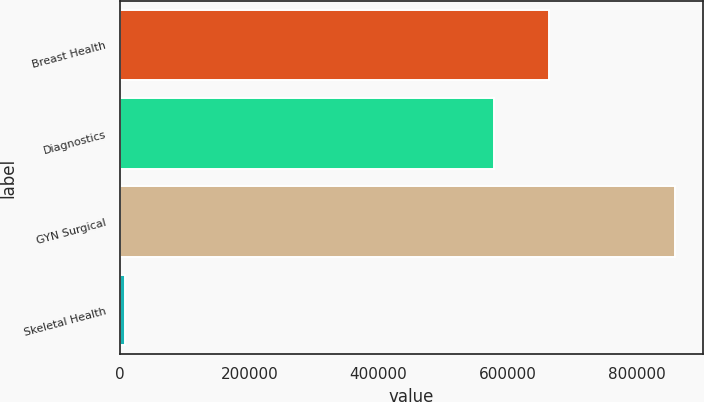Convert chart to OTSL. <chart><loc_0><loc_0><loc_500><loc_500><bar_chart><fcel>Breast Health<fcel>Diagnostics<fcel>GYN Surgical<fcel>Skeletal Health<nl><fcel>663444<fcel>578290<fcel>859739<fcel>8199<nl></chart> 